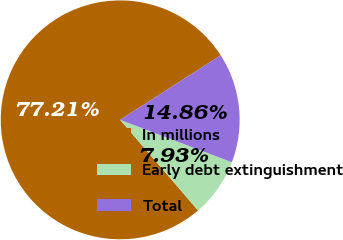Convert chart. <chart><loc_0><loc_0><loc_500><loc_500><pie_chart><fcel>In millions<fcel>Early debt extinguishment<fcel>Total<nl><fcel>77.21%<fcel>7.93%<fcel>14.86%<nl></chart> 